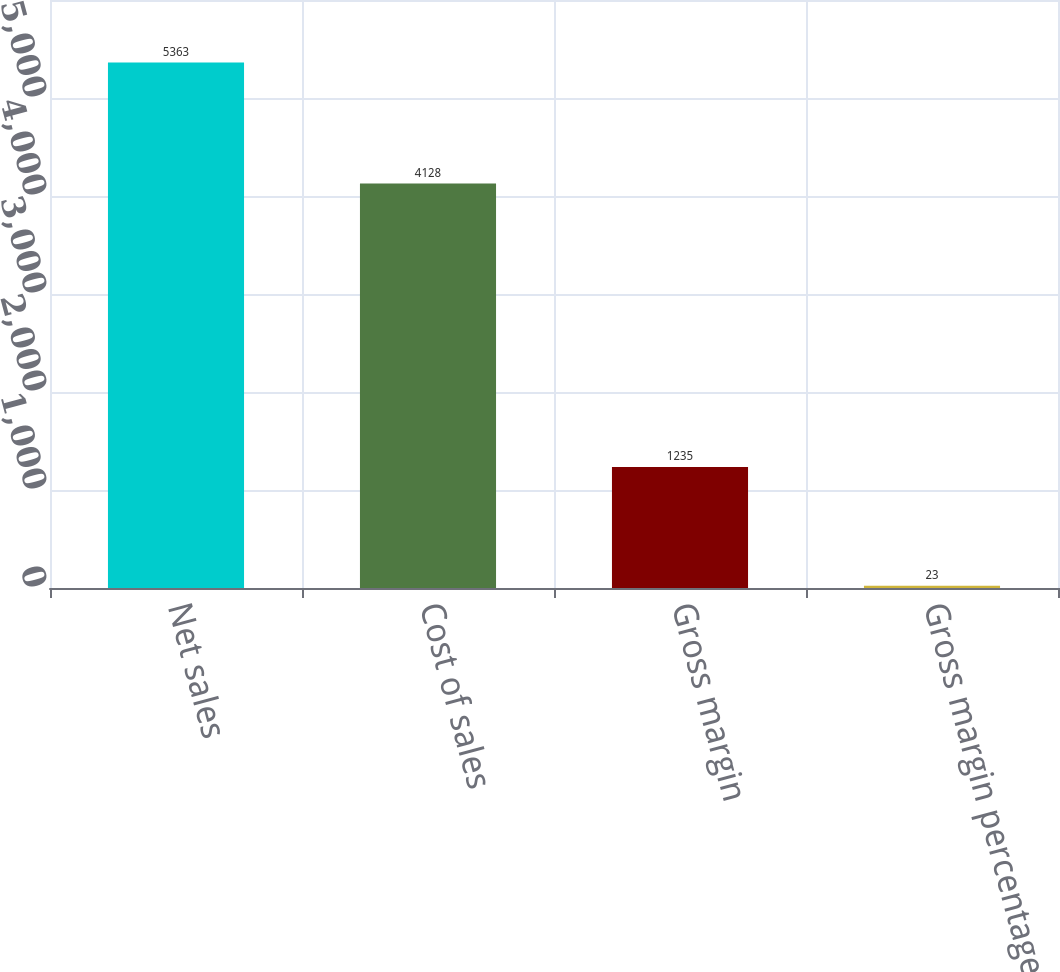Convert chart to OTSL. <chart><loc_0><loc_0><loc_500><loc_500><bar_chart><fcel>Net sales<fcel>Cost of sales<fcel>Gross margin<fcel>Gross margin percentage<nl><fcel>5363<fcel>4128<fcel>1235<fcel>23<nl></chart> 